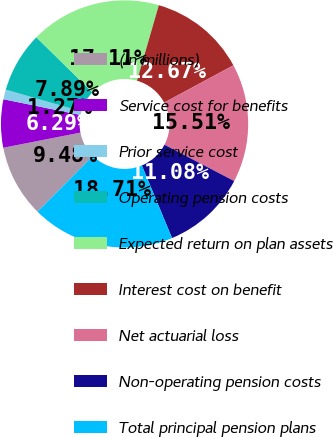<chart> <loc_0><loc_0><loc_500><loc_500><pie_chart><fcel>(In millions)<fcel>Service cost for benefits<fcel>Prior service cost<fcel>Operating pension costs<fcel>Expected return on plan assets<fcel>Interest cost on benefit<fcel>Net actuarial loss<fcel>Non-operating pension costs<fcel>Total principal pension plans<nl><fcel>9.48%<fcel>6.29%<fcel>1.27%<fcel>7.89%<fcel>17.11%<fcel>12.67%<fcel>15.51%<fcel>11.08%<fcel>18.71%<nl></chart> 